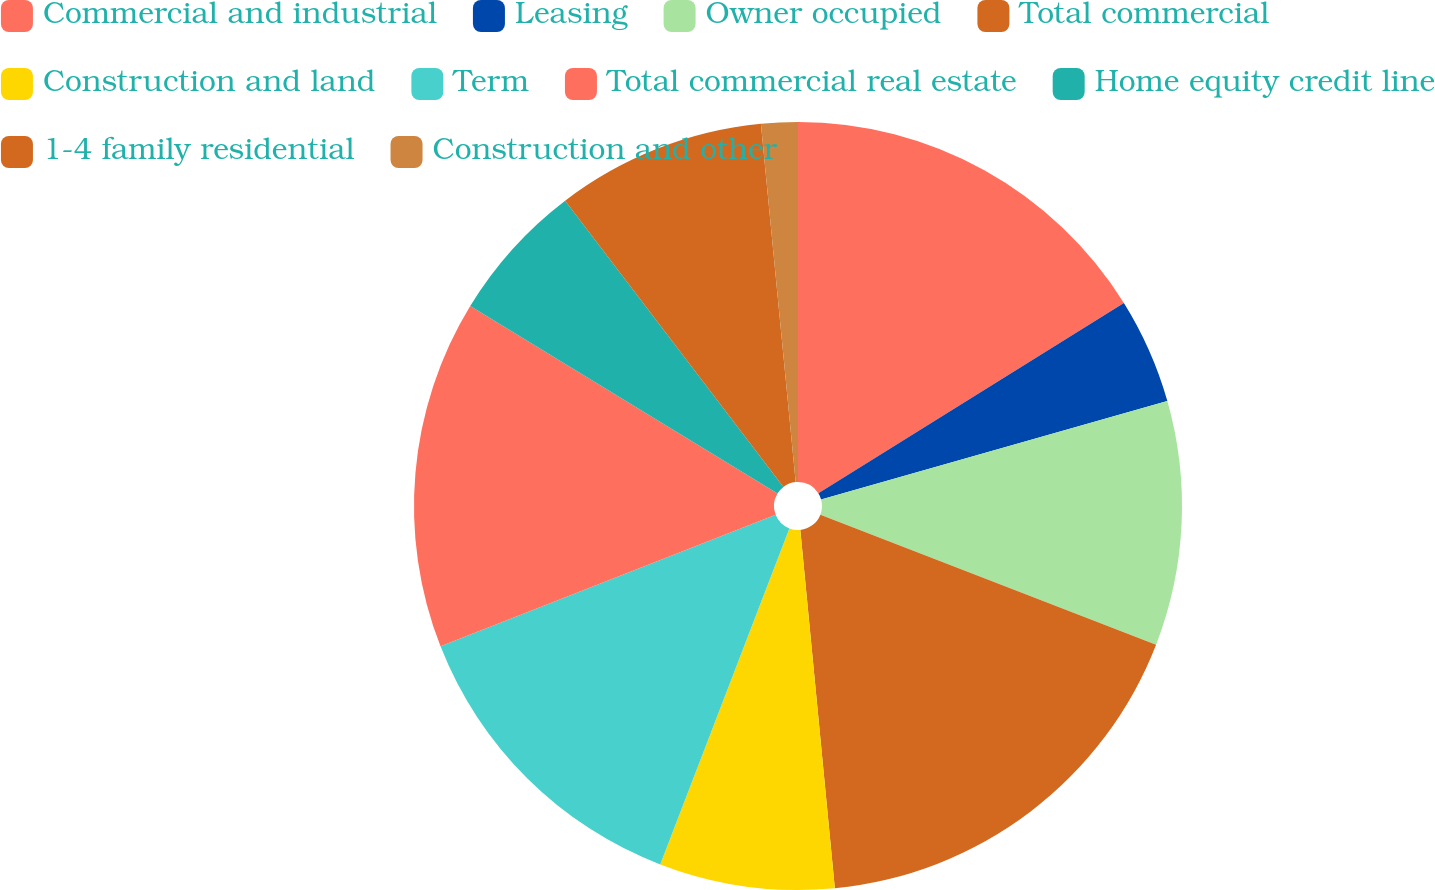Convert chart to OTSL. <chart><loc_0><loc_0><loc_500><loc_500><pie_chart><fcel>Commercial and industrial<fcel>Leasing<fcel>Owner occupied<fcel>Total commercial<fcel>Construction and land<fcel>Term<fcel>Total commercial real estate<fcel>Home equity credit line<fcel>1-4 family residential<fcel>Construction and other<nl><fcel>16.13%<fcel>4.46%<fcel>10.29%<fcel>17.59%<fcel>7.37%<fcel>13.21%<fcel>14.67%<fcel>5.91%<fcel>8.83%<fcel>1.54%<nl></chart> 